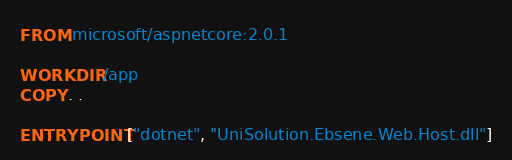<code> <loc_0><loc_0><loc_500><loc_500><_Dockerfile_>FROM microsoft/aspnetcore:2.0.1

WORKDIR /app
COPY . .

ENTRYPOINT ["dotnet", "UniSolution.Ebsene.Web.Host.dll"]
</code> 